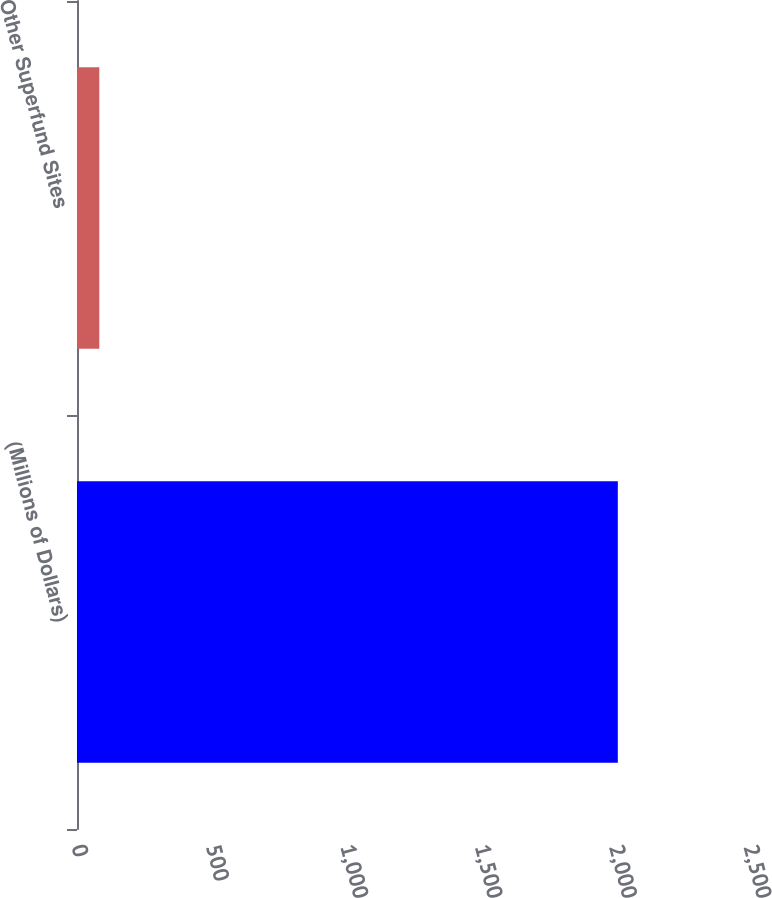Convert chart. <chart><loc_0><loc_0><loc_500><loc_500><bar_chart><fcel>(Millions of Dollars)<fcel>Other Superfund Sites<nl><fcel>2012<fcel>83<nl></chart> 